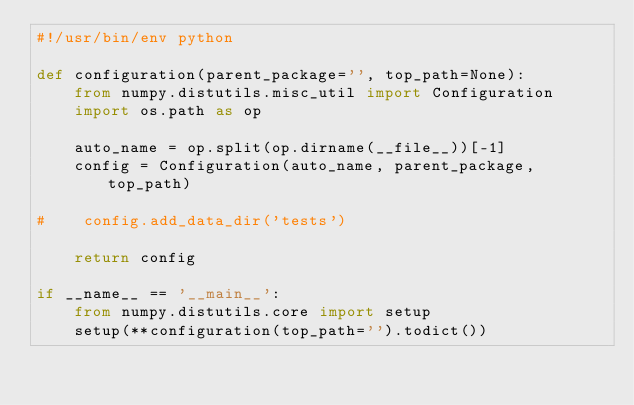Convert code to text. <code><loc_0><loc_0><loc_500><loc_500><_Python_>#!/usr/bin/env python

def configuration(parent_package='', top_path=None):
    from numpy.distutils.misc_util import Configuration
    import os.path as op

    auto_name = op.split(op.dirname(__file__))[-1]
    config = Configuration(auto_name, parent_package, top_path)

#    config.add_data_dir('tests')

    return config

if __name__ == '__main__':
    from numpy.distutils.core import setup
    setup(**configuration(top_path='').todict())
</code> 